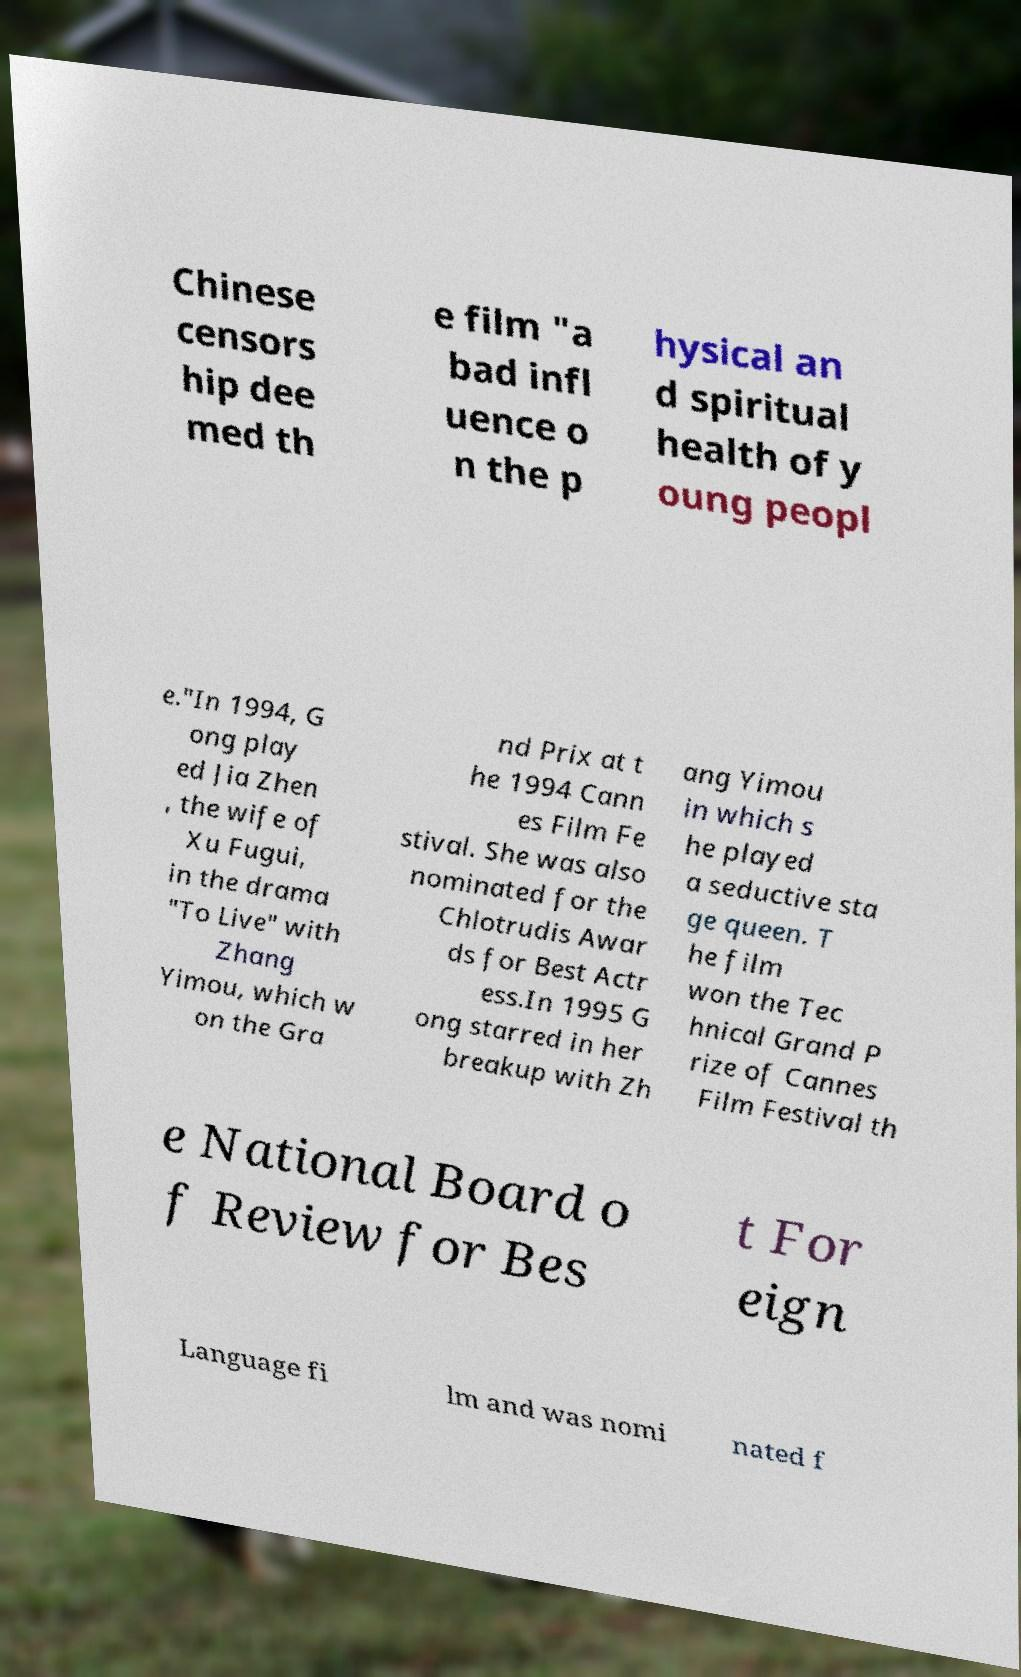Could you extract and type out the text from this image? Chinese censors hip dee med th e film "a bad infl uence o n the p hysical an d spiritual health of y oung peopl e."In 1994, G ong play ed Jia Zhen , the wife of Xu Fugui, in the drama "To Live" with Zhang Yimou, which w on the Gra nd Prix at t he 1994 Cann es Film Fe stival. She was also nominated for the Chlotrudis Awar ds for Best Actr ess.In 1995 G ong starred in her breakup with Zh ang Yimou in which s he played a seductive sta ge queen. T he film won the Tec hnical Grand P rize of Cannes Film Festival th e National Board o f Review for Bes t For eign Language fi lm and was nomi nated f 